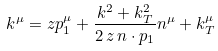<formula> <loc_0><loc_0><loc_500><loc_500>k ^ { \mu } = z p _ { 1 } ^ { \mu } + \frac { k ^ { 2 } + k _ { T } ^ { 2 } } { 2 \, z \, n \cdot p _ { 1 } } n ^ { \mu } + k _ { T } ^ { \mu }</formula> 